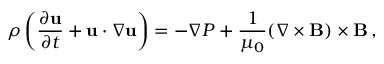Convert formula to latex. <formula><loc_0><loc_0><loc_500><loc_500>\rho \left ( { \frac { \partial { u } } { \partial t } } + { u } \cdot \nabla { u } \right ) = - \nabla P + { \frac { 1 } { \mu _ { 0 } } } ( \nabla \times { B } ) \times { B } \, ,</formula> 